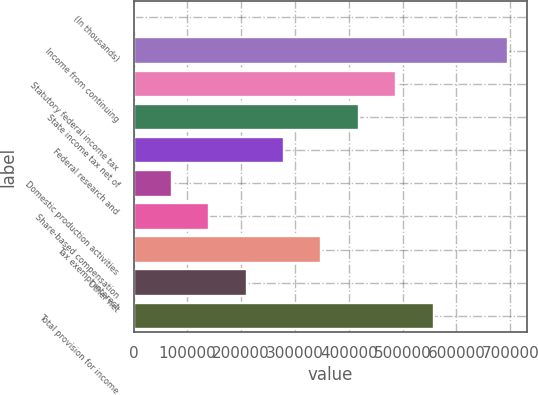Convert chart to OTSL. <chart><loc_0><loc_0><loc_500><loc_500><bar_chart><fcel>(In thousands)<fcel>Income from continuing<fcel>Statutory federal income tax<fcel>State income tax net of<fcel>Federal research and<fcel>Domestic production activities<fcel>Share-based compensation<fcel>Tax exempt interest<fcel>Other net<fcel>Total provision for income<nl><fcel>2007<fcel>696412<fcel>488090<fcel>418650<fcel>279769<fcel>71447.5<fcel>140888<fcel>349210<fcel>210328<fcel>557531<nl></chart> 